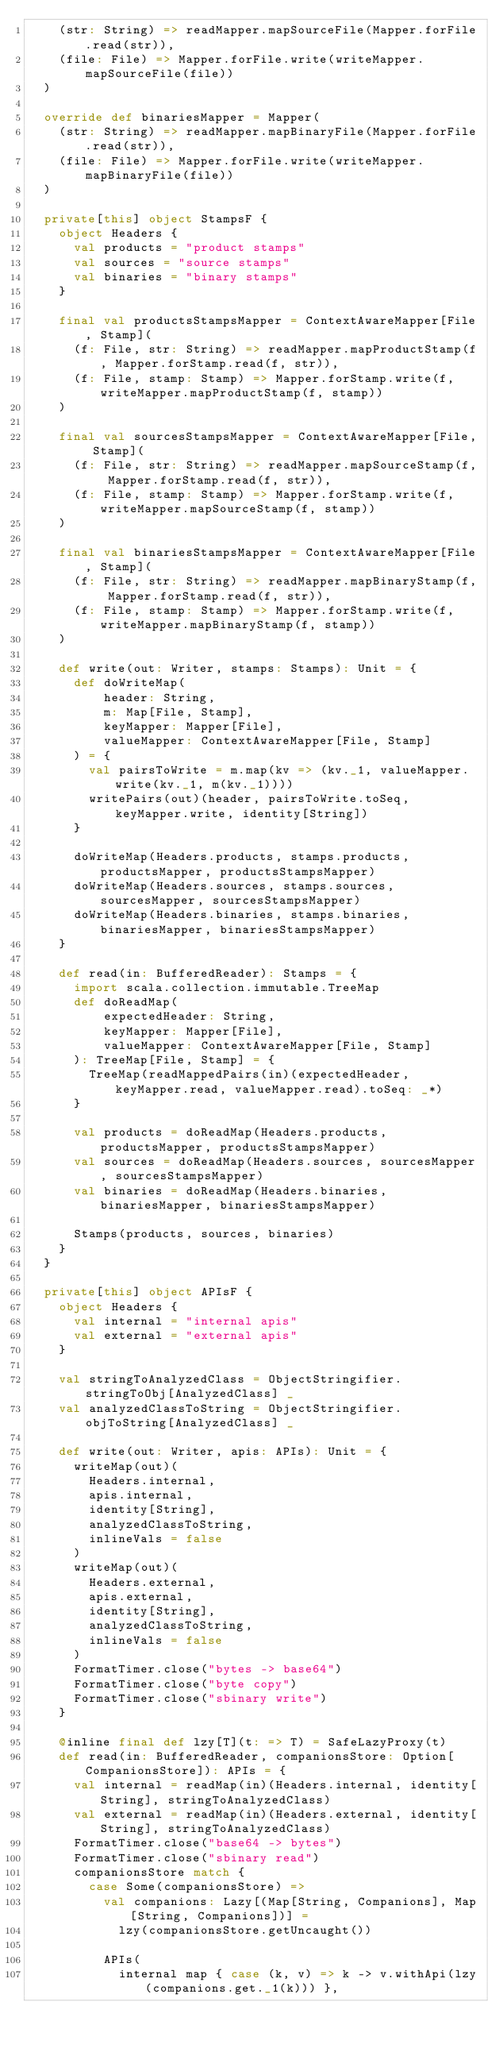<code> <loc_0><loc_0><loc_500><loc_500><_Scala_>    (str: String) => readMapper.mapSourceFile(Mapper.forFile.read(str)),
    (file: File) => Mapper.forFile.write(writeMapper.mapSourceFile(file))
  )

  override def binariesMapper = Mapper(
    (str: String) => readMapper.mapBinaryFile(Mapper.forFile.read(str)),
    (file: File) => Mapper.forFile.write(writeMapper.mapBinaryFile(file))
  )

  private[this] object StampsF {
    object Headers {
      val products = "product stamps"
      val sources = "source stamps"
      val binaries = "binary stamps"
    }

    final val productsStampsMapper = ContextAwareMapper[File, Stamp](
      (f: File, str: String) => readMapper.mapProductStamp(f, Mapper.forStamp.read(f, str)),
      (f: File, stamp: Stamp) => Mapper.forStamp.write(f, writeMapper.mapProductStamp(f, stamp))
    )

    final val sourcesStampsMapper = ContextAwareMapper[File, Stamp](
      (f: File, str: String) => readMapper.mapSourceStamp(f, Mapper.forStamp.read(f, str)),
      (f: File, stamp: Stamp) => Mapper.forStamp.write(f, writeMapper.mapSourceStamp(f, stamp))
    )

    final val binariesStampsMapper = ContextAwareMapper[File, Stamp](
      (f: File, str: String) => readMapper.mapBinaryStamp(f, Mapper.forStamp.read(f, str)),
      (f: File, stamp: Stamp) => Mapper.forStamp.write(f, writeMapper.mapBinaryStamp(f, stamp))
    )

    def write(out: Writer, stamps: Stamps): Unit = {
      def doWriteMap(
          header: String,
          m: Map[File, Stamp],
          keyMapper: Mapper[File],
          valueMapper: ContextAwareMapper[File, Stamp]
      ) = {
        val pairsToWrite = m.map(kv => (kv._1, valueMapper.write(kv._1, m(kv._1))))
        writePairs(out)(header, pairsToWrite.toSeq, keyMapper.write, identity[String])
      }

      doWriteMap(Headers.products, stamps.products, productsMapper, productsStampsMapper)
      doWriteMap(Headers.sources, stamps.sources, sourcesMapper, sourcesStampsMapper)
      doWriteMap(Headers.binaries, stamps.binaries, binariesMapper, binariesStampsMapper)
    }

    def read(in: BufferedReader): Stamps = {
      import scala.collection.immutable.TreeMap
      def doReadMap(
          expectedHeader: String,
          keyMapper: Mapper[File],
          valueMapper: ContextAwareMapper[File, Stamp]
      ): TreeMap[File, Stamp] = {
        TreeMap(readMappedPairs(in)(expectedHeader, keyMapper.read, valueMapper.read).toSeq: _*)
      }

      val products = doReadMap(Headers.products, productsMapper, productsStampsMapper)
      val sources = doReadMap(Headers.sources, sourcesMapper, sourcesStampsMapper)
      val binaries = doReadMap(Headers.binaries, binariesMapper, binariesStampsMapper)

      Stamps(products, sources, binaries)
    }
  }

  private[this] object APIsF {
    object Headers {
      val internal = "internal apis"
      val external = "external apis"
    }

    val stringToAnalyzedClass = ObjectStringifier.stringToObj[AnalyzedClass] _
    val analyzedClassToString = ObjectStringifier.objToString[AnalyzedClass] _

    def write(out: Writer, apis: APIs): Unit = {
      writeMap(out)(
        Headers.internal,
        apis.internal,
        identity[String],
        analyzedClassToString,
        inlineVals = false
      )
      writeMap(out)(
        Headers.external,
        apis.external,
        identity[String],
        analyzedClassToString,
        inlineVals = false
      )
      FormatTimer.close("bytes -> base64")
      FormatTimer.close("byte copy")
      FormatTimer.close("sbinary write")
    }

    @inline final def lzy[T](t: => T) = SafeLazyProxy(t)
    def read(in: BufferedReader, companionsStore: Option[CompanionsStore]): APIs = {
      val internal = readMap(in)(Headers.internal, identity[String], stringToAnalyzedClass)
      val external = readMap(in)(Headers.external, identity[String], stringToAnalyzedClass)
      FormatTimer.close("base64 -> bytes")
      FormatTimer.close("sbinary read")
      companionsStore match {
        case Some(companionsStore) =>
          val companions: Lazy[(Map[String, Companions], Map[String, Companions])] =
            lzy(companionsStore.getUncaught())

          APIs(
            internal map { case (k, v) => k -> v.withApi(lzy(companions.get._1(k))) },</code> 